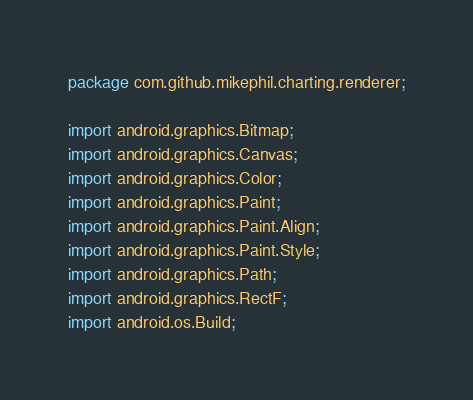Convert code to text. <code><loc_0><loc_0><loc_500><loc_500><_Java_>
package com.github.mikephil.charting.renderer;

import android.graphics.Bitmap;
import android.graphics.Canvas;
import android.graphics.Color;
import android.graphics.Paint;
import android.graphics.Paint.Align;
import android.graphics.Paint.Style;
import android.graphics.Path;
import android.graphics.RectF;
import android.os.Build;</code> 